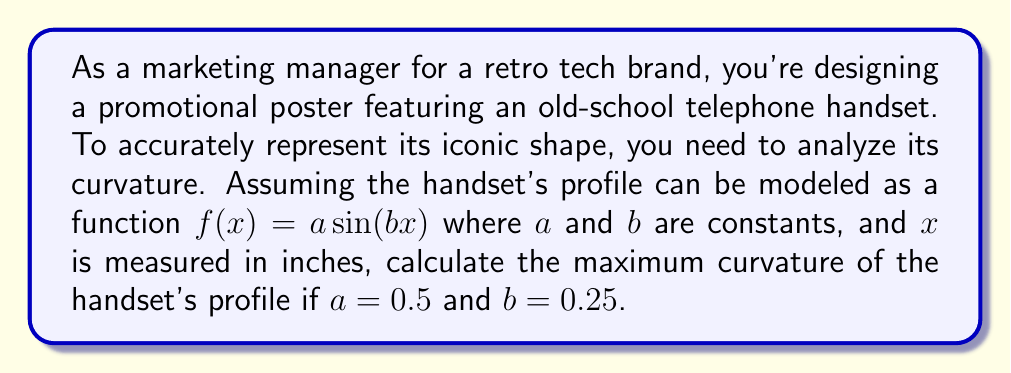Provide a solution to this math problem. To analyze the curvature of the old-school telephone handset, we'll follow these steps:

1) The curvature $\kappa$ of a function $y = f(x)$ is given by:

   $$\kappa = \frac{|f''(x)|}{(1 + [f'(x)]^2)^{3/2}}$$

2) For our function $f(x) = a\sin(bx)$, we need to find $f'(x)$ and $f''(x)$:

   $f'(x) = ab\cos(bx)$
   $f''(x) = -ab^2\sin(bx)$

3) Substituting these into the curvature formula:

   $$\kappa = \frac{|ab^2\sin(bx)|}{(1 + [ab\cos(bx)]^2)^{3/2}}$$

4) The maximum curvature will occur when $|\sin(bx)| = 1$ and $\cos(bx) = 0$, i.e., when $bx = \frac{\pi}{2}$ or $\frac{3\pi}{2}$.

5) At these points, the curvature simplifies to:

   $$\kappa_{max} = ab^2$$

6) Substituting the given values $a = 0.5$ and $b = 0.25$:

   $$\kappa_{max} = 0.5 * (0.25)^2 = 0.5 * 0.0625 = 0.03125$$

Therefore, the maximum curvature of the handset's profile is 0.03125 per inch.
Answer: The maximum curvature of the old-school telephone handset's profile is 0.03125 per inch. 